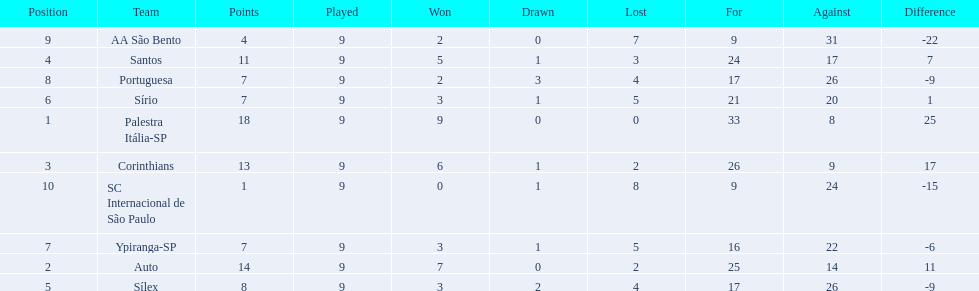What were all the teams that competed in 1926 brazilian football? Palestra Itália-SP, Auto, Corinthians, Santos, Sílex, Sírio, Ypiranga-SP, Portuguesa, AA São Bento, SC Internacional de São Paulo. Which of these had zero games lost? Palestra Itália-SP. 